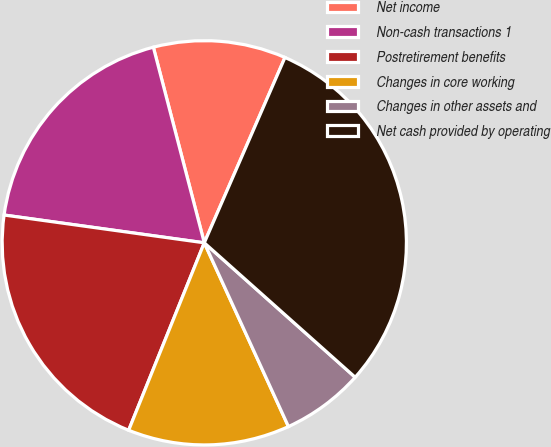Convert chart. <chart><loc_0><loc_0><loc_500><loc_500><pie_chart><fcel>Net income<fcel>Non-cash transactions 1<fcel>Postretirement benefits<fcel>Changes in core working<fcel>Changes in other assets and<fcel>Net cash provided by operating<nl><fcel>10.59%<fcel>18.75%<fcel>21.09%<fcel>12.94%<fcel>6.58%<fcel>30.05%<nl></chart> 